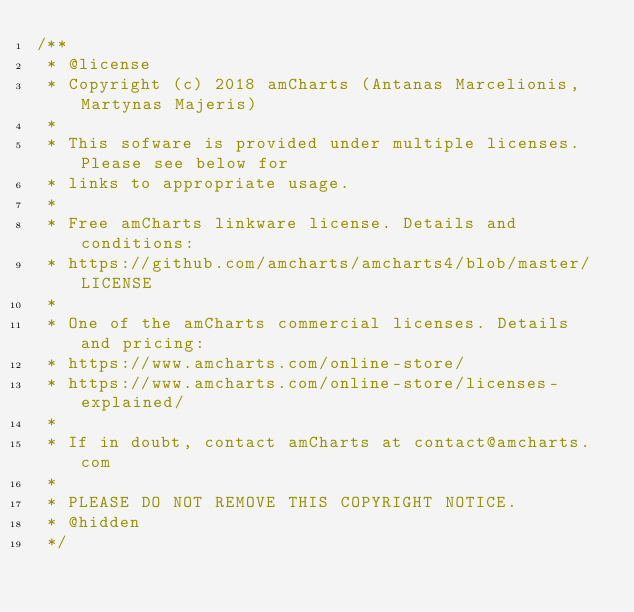Convert code to text. <code><loc_0><loc_0><loc_500><loc_500><_JavaScript_>/**
 * @license
 * Copyright (c) 2018 amCharts (Antanas Marcelionis, Martynas Majeris)
 *
 * This sofware is provided under multiple licenses. Please see below for
 * links to appropriate usage.
 *
 * Free amCharts linkware license. Details and conditions:
 * https://github.com/amcharts/amcharts4/blob/master/LICENSE
 *
 * One of the amCharts commercial licenses. Details and pricing:
 * https://www.amcharts.com/online-store/
 * https://www.amcharts.com/online-store/licenses-explained/
 *
 * If in doubt, contact amCharts at contact@amcharts.com
 *
 * PLEASE DO NOT REMOVE THIS COPYRIGHT NOTICE.
 * @hidden
 */</code> 